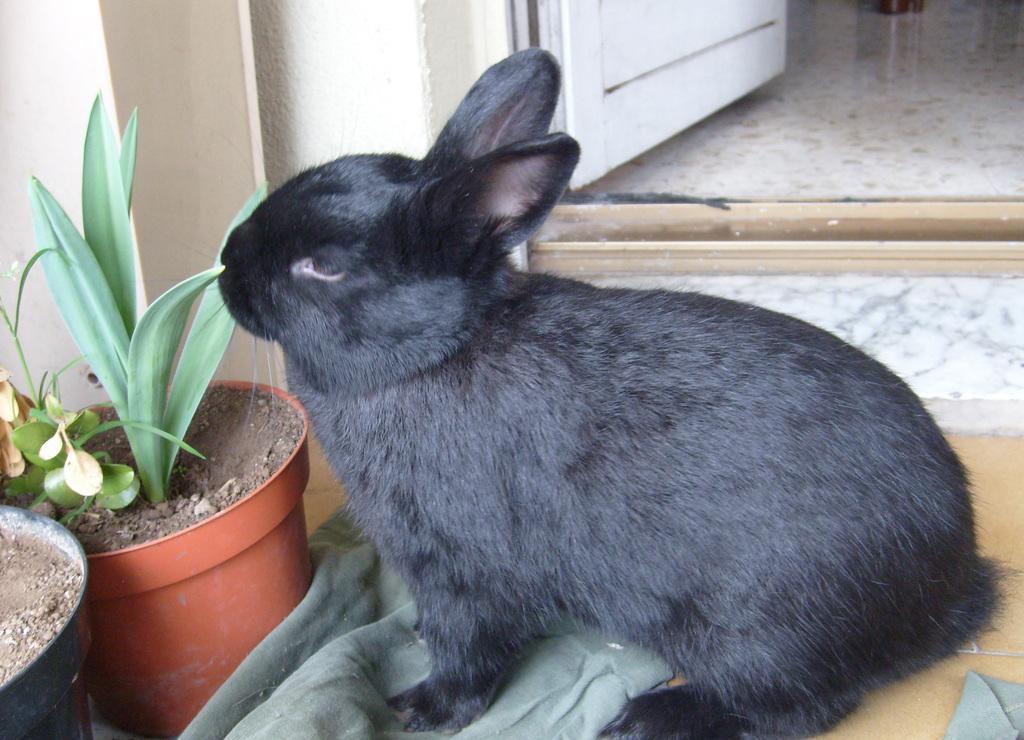Please provide a concise description of this image. In this image I can see an animal, a cloth,plants, pots,a door and there is a marble floor. 